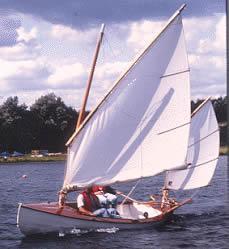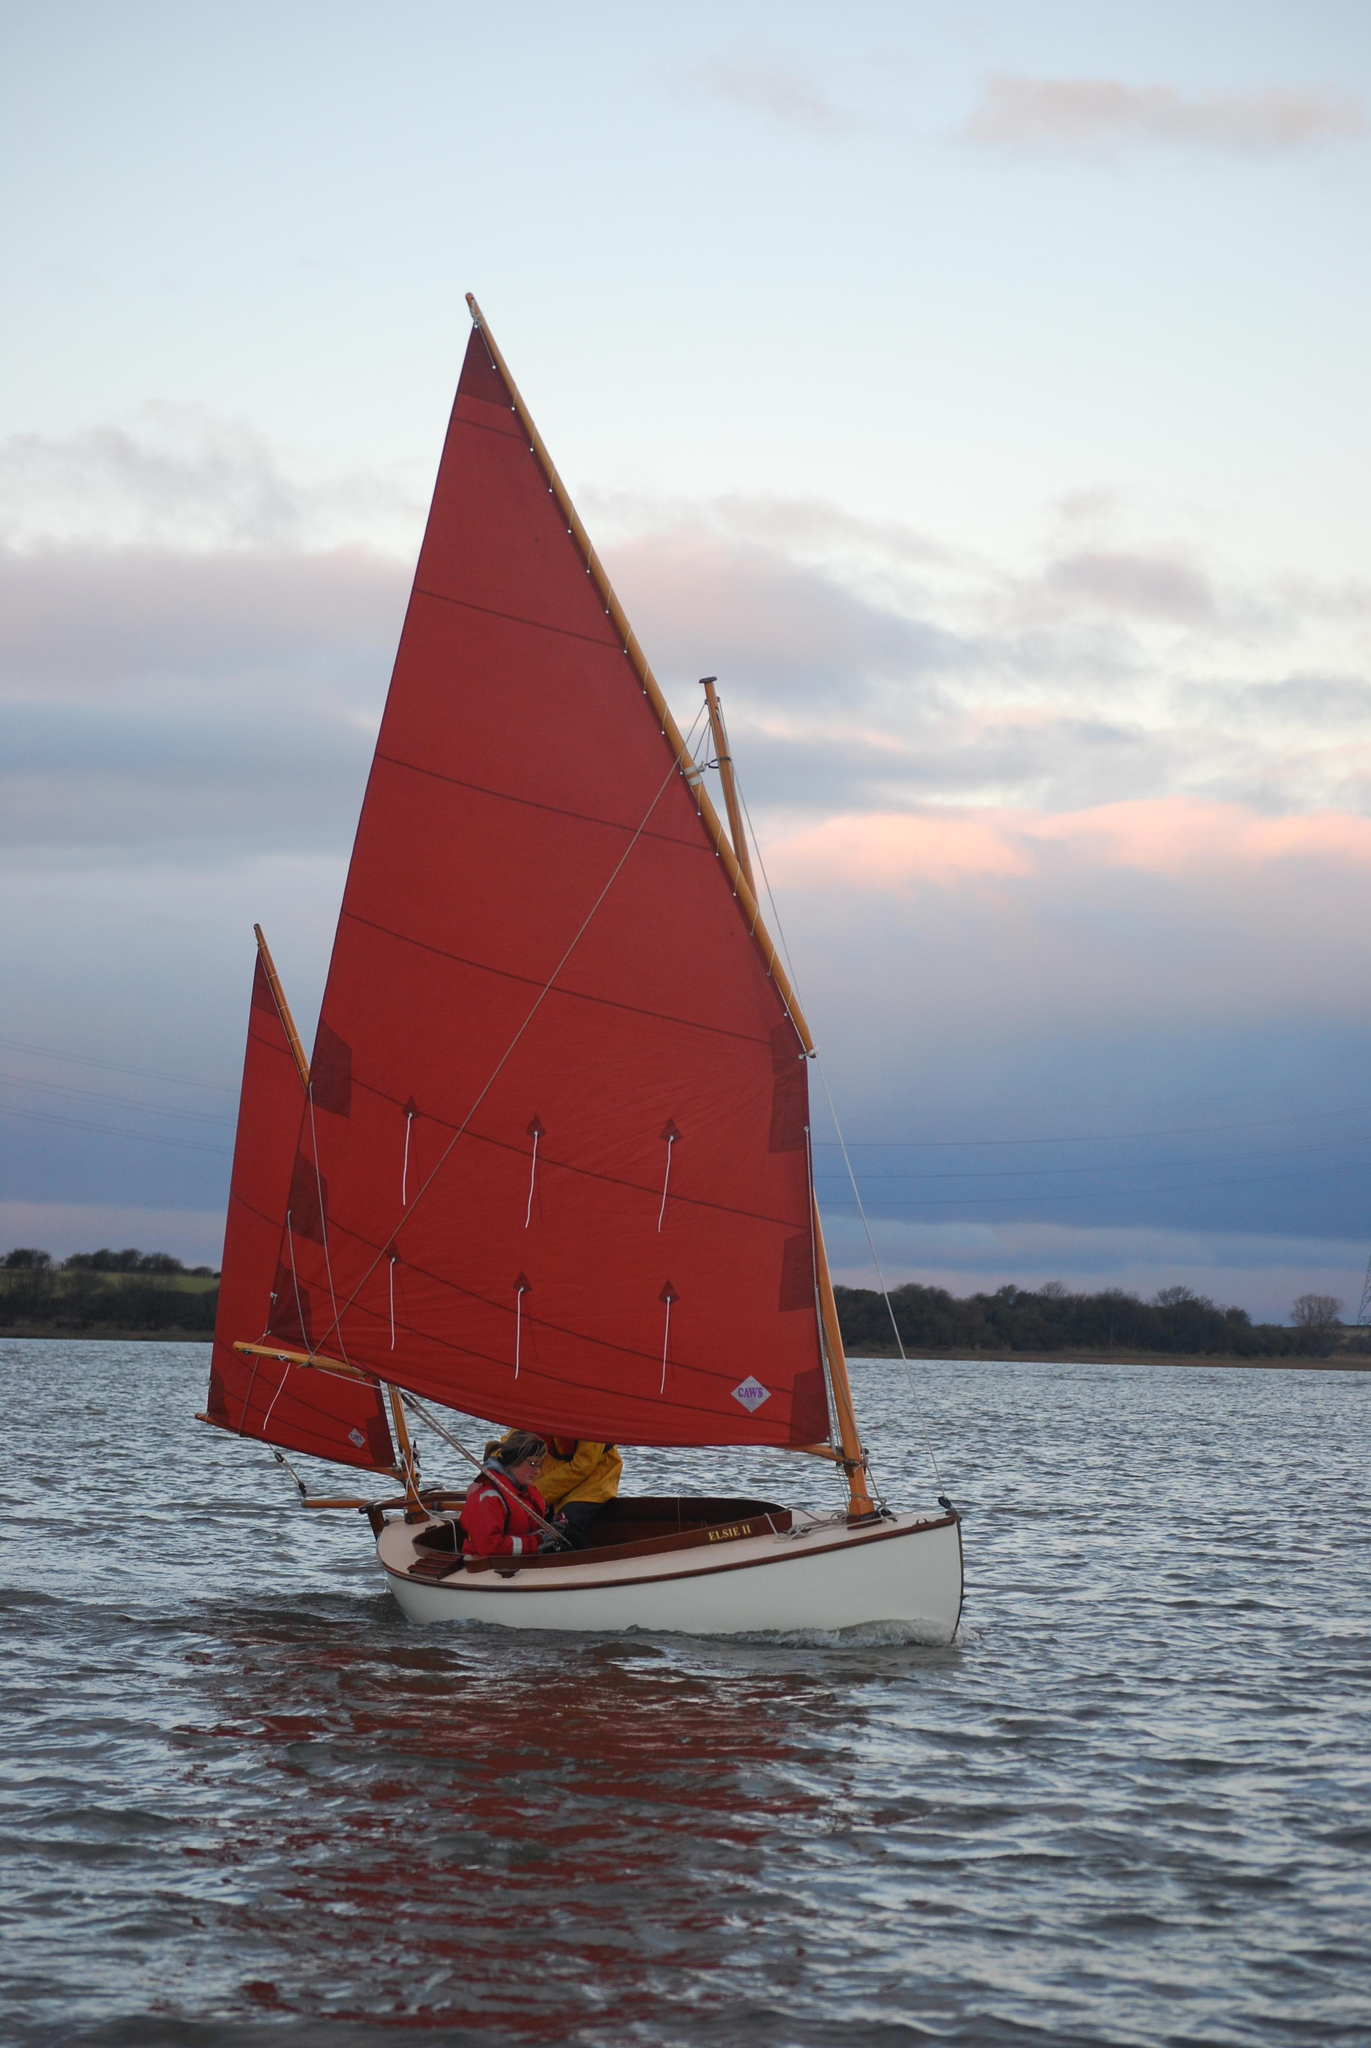The first image is the image on the left, the second image is the image on the right. For the images displayed, is the sentence "All of the sails on the boat in the image to the right happen to be red." factually correct? Answer yes or no. Yes. The first image is the image on the left, the second image is the image on the right. For the images displayed, is the sentence "in the right pic the nearest pic has three sails" factually correct? Answer yes or no. No. 